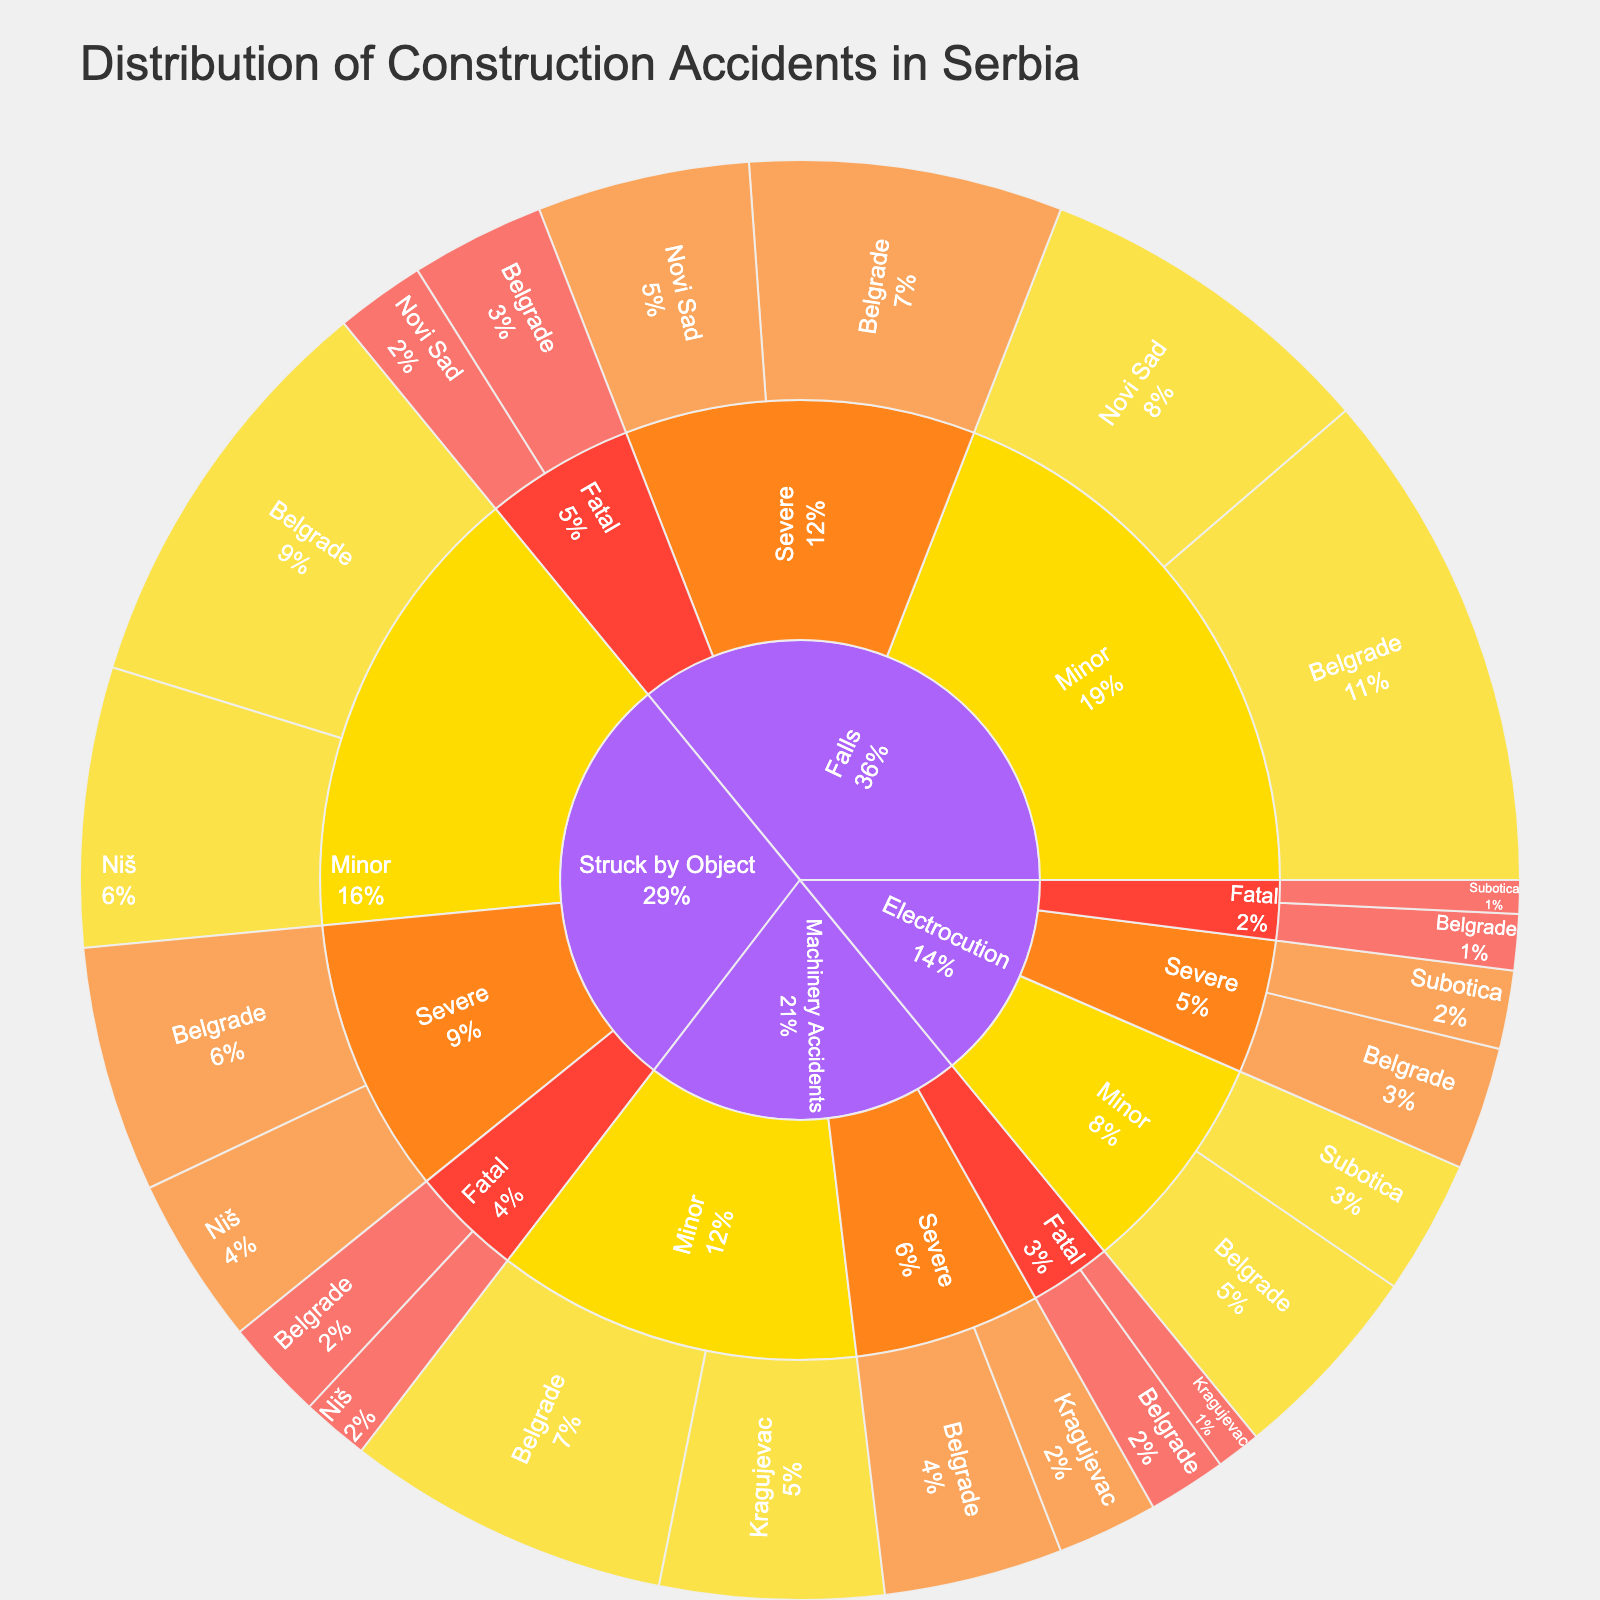what's the title of the figure? The title is prominently displayed at the top of the sunburst plot.
Answer: Distribution of Construction Accidents in Serbia what type of accidents have the highest value in Belgrade? By visually inspecting the figure, we can observe the sunburst plot sections that represent different types of accidents in Belgrade and compare their sizes.
Answer: Falls how many fatal electrocutions happened in Subotica? Look for the "Electrocution" section, then the severity "Fatal," and finally the location "Subotica." The value is indicated.
Answer: 3 what's the sum of severe accidents in Belgrade? Focus on the "Severe" sections within Belgrade for each type of accident and sum their values: Falls (28), Struck by Object (22), Electrocution (11), Machinery Accidents (16). 28 + 22 + 11 + 16 = 77.
Answer: 77 which location has the most minor accidents from being struck by an object? Compare the "Minor" sections under "Struck by Object" for each location to determine which one has the highest value.
Answer: Belgrade which type of accident has more fatal cases, falls or machinery accidents? Compare the values under "Fatal" for "Falls" and "Machinery Accidents." Falls have the values (12 in Belgrade, 8 in Novi Sad), Machinery Accidents have (7 in Belgrade, 4 in Kragujevac). Falls: 12 + 8 = 20, Machinery Accidents: 7 + 4 = 11.
Answer: Falls what's the ratio of severe to minor machinery accidents in Kragujevac? Identify the values for "Severe" and "Minor" under "Machinery Accidents" in Kragujevac. Severe: 9, Minor: 20. The ratio is 9/20.
Answer: 9:20 how many severe accidents happened in Niš? Sum the values under "Severe" for each type of accident in Niš: Struck by Object (15)
Answer: 15 which accident type has the least number of minor cases in Belgrade? Compare the values for "Minor" under each type of accident in Belgrade to identify the smallest one. Falls (45), Struck by Object (37), Electrocution (18), Machinery Accidents (29).
Answer: Electrocution what is the percentage of minor falls in Belgrade compared to all minor falls in Serbia? Calculate the total minor falls in Serbia by summing all related values: Belgrade (45), Novi Sad (31). Then compute the percentage: (Belgrade 45 / Total 45+31) * 100 = (45/76) * 100.
Answer: approx. 59.21% 